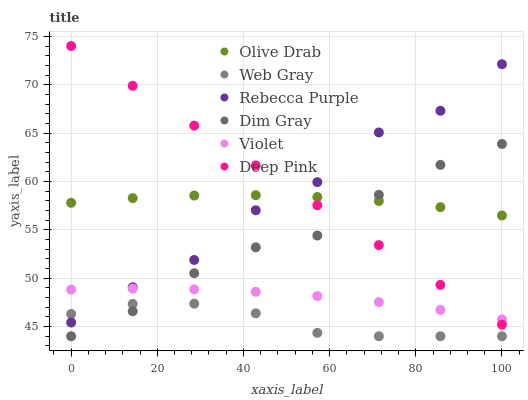Does Web Gray have the minimum area under the curve?
Answer yes or no. Yes. Does Deep Pink have the maximum area under the curve?
Answer yes or no. Yes. Does Dim Gray have the minimum area under the curve?
Answer yes or no. No. Does Dim Gray have the maximum area under the curve?
Answer yes or no. No. Is Deep Pink the smoothest?
Answer yes or no. Yes. Is Rebecca Purple the roughest?
Answer yes or no. Yes. Is Dim Gray the smoothest?
Answer yes or no. No. Is Dim Gray the roughest?
Answer yes or no. No. Does Dim Gray have the lowest value?
Answer yes or no. Yes. Does Rebecca Purple have the lowest value?
Answer yes or no. No. Does Deep Pink have the highest value?
Answer yes or no. Yes. Does Dim Gray have the highest value?
Answer yes or no. No. Is Web Gray less than Violet?
Answer yes or no. Yes. Is Rebecca Purple greater than Dim Gray?
Answer yes or no. Yes. Does Deep Pink intersect Rebecca Purple?
Answer yes or no. Yes. Is Deep Pink less than Rebecca Purple?
Answer yes or no. No. Is Deep Pink greater than Rebecca Purple?
Answer yes or no. No. Does Web Gray intersect Violet?
Answer yes or no. No. 